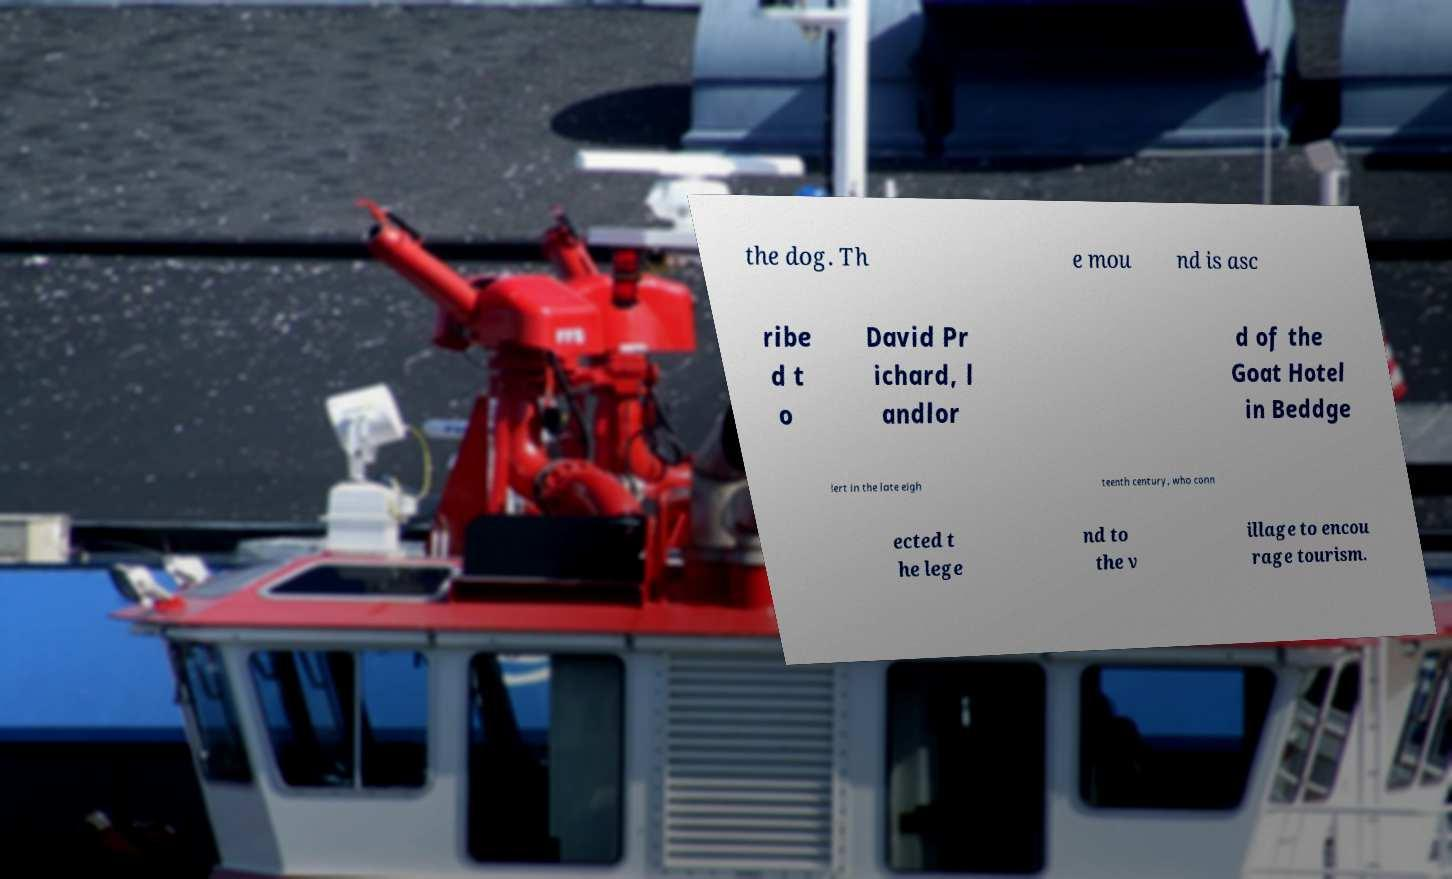Could you extract and type out the text from this image? the dog. Th e mou nd is asc ribe d t o David Pr ichard, l andlor d of the Goat Hotel in Beddge lert in the late eigh teenth century, who conn ected t he lege nd to the v illage to encou rage tourism. 